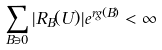Convert formula to latex. <formula><loc_0><loc_0><loc_500><loc_500>\sum _ { B \ni 0 } | R _ { B } ( U ) | e ^ { r g ( B ) } < \infty</formula> 